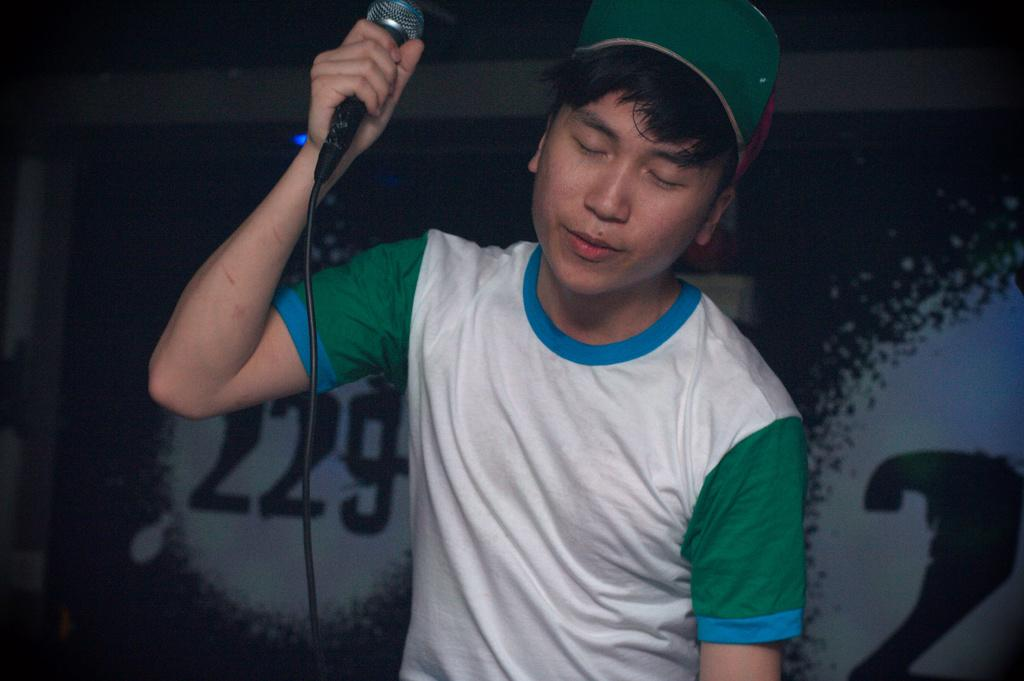What is the person in the image holding? The person is holding a microphone. Can you describe the person's headwear in the image? The person is wearing a cap. What can be seen in the background of the image? There is a banner in the background of the image. What type of cup is being used for the discussion in the image? There is no cup or discussion present in the image. How does the quartz contribute to the performance in the image? There is no quartz present in the image. 